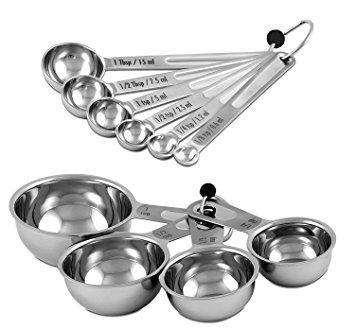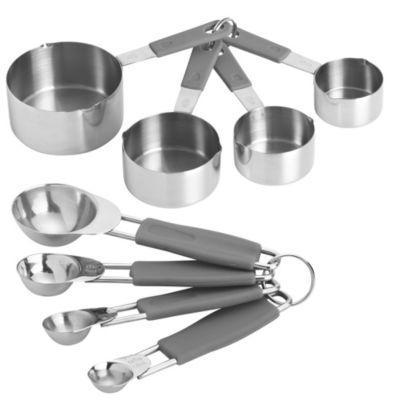The first image is the image on the left, the second image is the image on the right. Examine the images to the left and right. Is the description "Exactly two sets of measuring cups and spoons are fanned for display." accurate? Answer yes or no. Yes. 